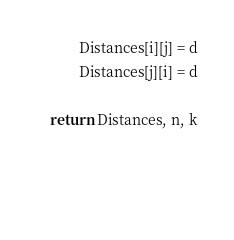Convert code to text. <code><loc_0><loc_0><loc_500><loc_500><_Python_>            Distances[i][j] = d
            Distances[j][i] = d

    return Distances, n, k
    

        
</code> 